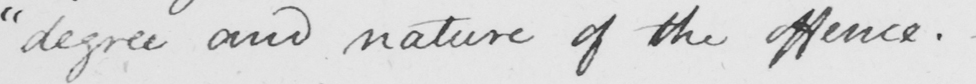Transcribe the text shown in this historical manuscript line. " degree and nature of the offence .  _ 